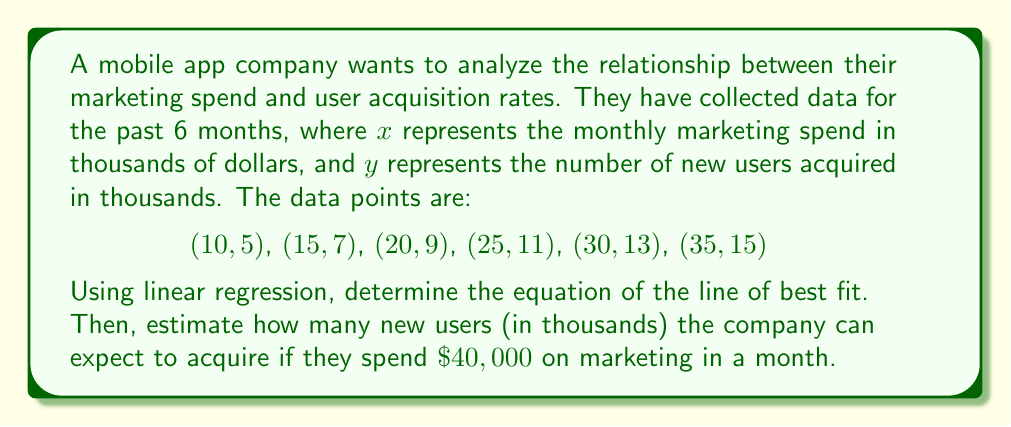Solve this math problem. To solve this problem, we'll use the linear regression equation:
$$y = mx + b$$

Where $m$ is the slope and $b$ is the y-intercept.

Step 1: Calculate the slope $m$ using the formula:
$$m = \frac{n\sum xy - \sum x \sum y}{n\sum x^2 - (\sum x)^2}$$

Step 2: Calculate $\sum x$, $\sum y$, $\sum xy$, and $\sum x^2$:
$\sum x = 10 + 15 + 20 + 25 + 30 + 35 = 135$
$\sum y = 5 + 7 + 9 + 11 + 13 + 15 = 60$
$\sum xy = 50 + 105 + 180 + 275 + 390 + 525 = 1525$
$\sum x^2 = 100 + 225 + 400 + 625 + 900 + 1225 = 3475$

Step 3: Substitute these values into the slope formula:
$$m = \frac{6(1525) - 135(60)}{6(3475) - 135^2} = \frac{9150 - 8100}{20850 - 18225} = \frac{1050}{2625} = 0.4$$

Step 4: Calculate the y-intercept $b$ using the formula:
$$b = \frac{\sum y - m\sum x}{n}$$
$$b = \frac{60 - 0.4(135)}{6} = \frac{60 - 54}{6} = 1$$

Step 5: Write the equation of the line of best fit:
$$y = 0.4x + 1$$

Step 6: Estimate the number of new users for $\$40,000$ marketing spend:
$$y = 0.4(40) + 1 = 16 + 1 = 17$$

Therefore, the company can expect to acquire approximately 17,000 new users with a $\$40,000$ marketing spend.
Answer: $y = 0.4x + 1$; 17,000 new users 